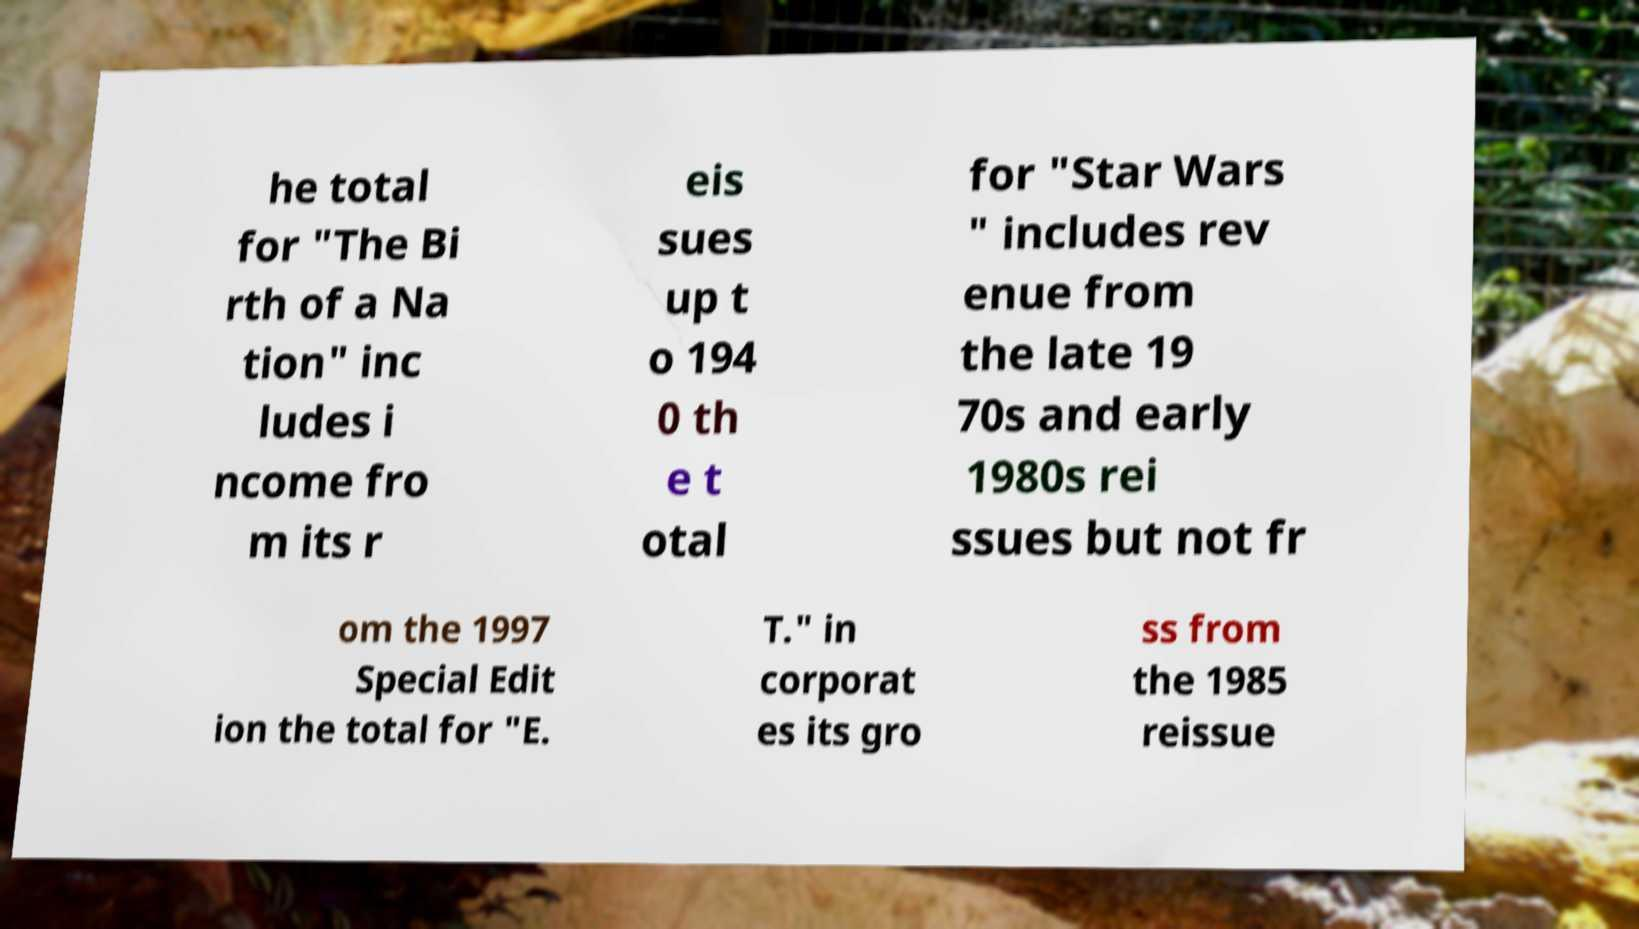Please read and relay the text visible in this image. What does it say? he total for "The Bi rth of a Na tion" inc ludes i ncome fro m its r eis sues up t o 194 0 th e t otal for "Star Wars " includes rev enue from the late 19 70s and early 1980s rei ssues but not fr om the 1997 Special Edit ion the total for "E. T." in corporat es its gro ss from the 1985 reissue 